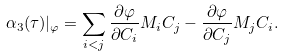Convert formula to latex. <formula><loc_0><loc_0><loc_500><loc_500>\alpha _ { 3 } ( \tau ) | _ { \varphi } = \sum _ { i < j } \frac { \partial \varphi } { \partial C _ { i } } M _ { i } C _ { j } - \frac { \partial \varphi } { \partial C _ { j } } M _ { j } C _ { i } .</formula> 